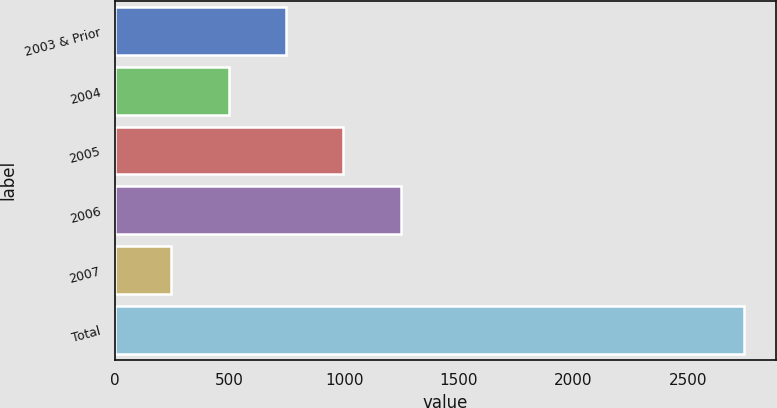Convert chart to OTSL. <chart><loc_0><loc_0><loc_500><loc_500><bar_chart><fcel>2003 & Prior<fcel>2004<fcel>2005<fcel>2006<fcel>2007<fcel>Total<nl><fcel>745.6<fcel>495.3<fcel>995.9<fcel>1246.2<fcel>245<fcel>2748<nl></chart> 